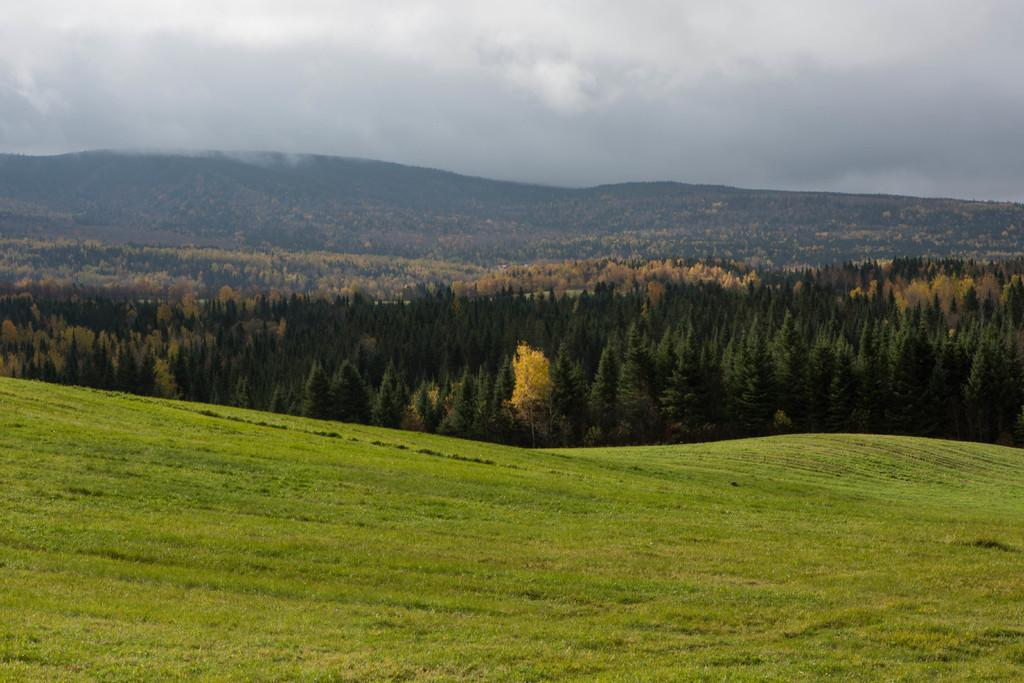What type of terrain is visible in the image? There is a mountain covered with grass in the image. What is located behind the mountain in the image? There are trees behind the mountain in the image. What else can be seen beyond the trees in the image? There are additional mountains behind the trees in the image. What part of the natural environment is visible in the image? The sky is visible in the image. What can be observed in the sky in the image? There are clouds in the sky. Where is the spade being used in the image? There is no spade present in the image. What type of ornament is hanging from the trees in the image? There are no ornaments visible in the image; only trees, mountains, and clouds are present. 